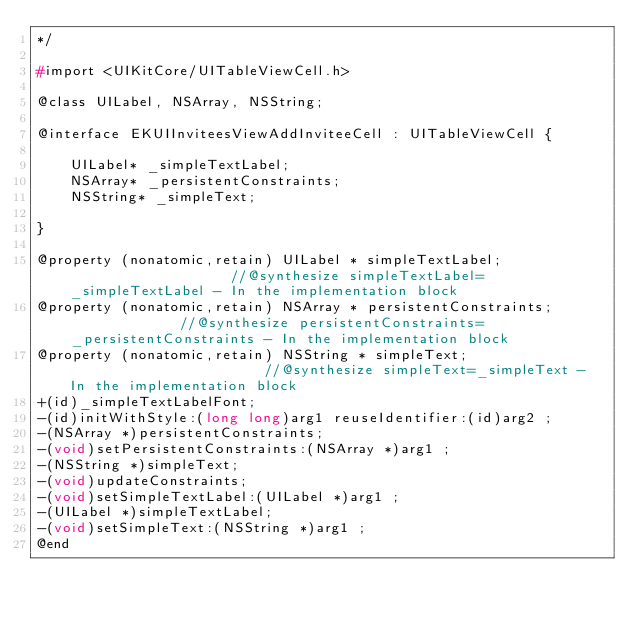<code> <loc_0><loc_0><loc_500><loc_500><_C_>*/

#import <UIKitCore/UITableViewCell.h>

@class UILabel, NSArray, NSString;

@interface EKUIInviteesViewAddInviteeCell : UITableViewCell {

	UILabel* _simpleTextLabel;
	NSArray* _persistentConstraints;
	NSString* _simpleText;

}

@property (nonatomic,retain) UILabel * simpleTextLabel;                    //@synthesize simpleTextLabel=_simpleTextLabel - In the implementation block
@property (nonatomic,retain) NSArray * persistentConstraints;              //@synthesize persistentConstraints=_persistentConstraints - In the implementation block
@property (nonatomic,retain) NSString * simpleText;                        //@synthesize simpleText=_simpleText - In the implementation block
+(id)_simpleTextLabelFont;
-(id)initWithStyle:(long long)arg1 reuseIdentifier:(id)arg2 ;
-(NSArray *)persistentConstraints;
-(void)setPersistentConstraints:(NSArray *)arg1 ;
-(NSString *)simpleText;
-(void)updateConstraints;
-(void)setSimpleTextLabel:(UILabel *)arg1 ;
-(UILabel *)simpleTextLabel;
-(void)setSimpleText:(NSString *)arg1 ;
@end

</code> 